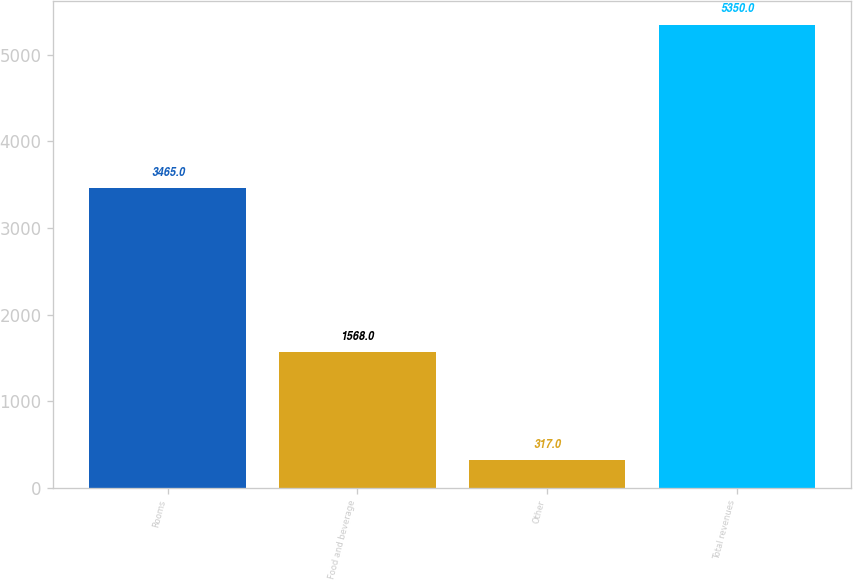Convert chart to OTSL. <chart><loc_0><loc_0><loc_500><loc_500><bar_chart><fcel>Rooms<fcel>Food and beverage<fcel>Other<fcel>Total revenues<nl><fcel>3465<fcel>1568<fcel>317<fcel>5350<nl></chart> 